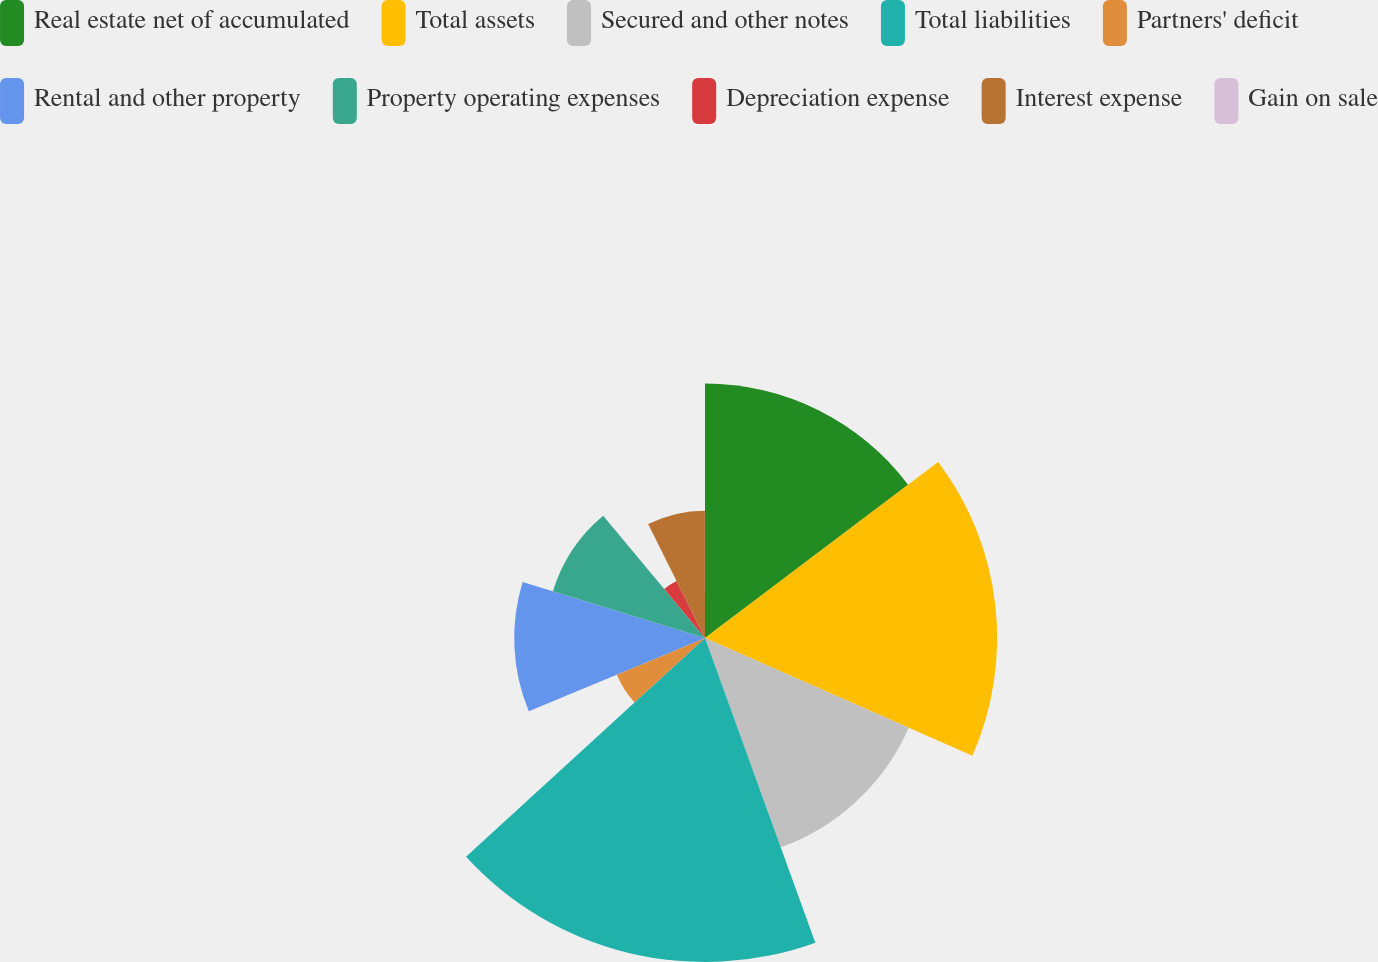Convert chart. <chart><loc_0><loc_0><loc_500><loc_500><pie_chart><fcel>Real estate net of accumulated<fcel>Total assets<fcel>Secured and other notes<fcel>Total liabilities<fcel>Partners' deficit<fcel>Rental and other property<fcel>Property operating expenses<fcel>Depreciation expense<fcel>Interest expense<fcel>Gain on sale<nl><fcel>14.71%<fcel>16.89%<fcel>12.87%<fcel>18.73%<fcel>5.52%<fcel>11.03%<fcel>9.2%<fcel>3.68%<fcel>7.36%<fcel>0.01%<nl></chart> 